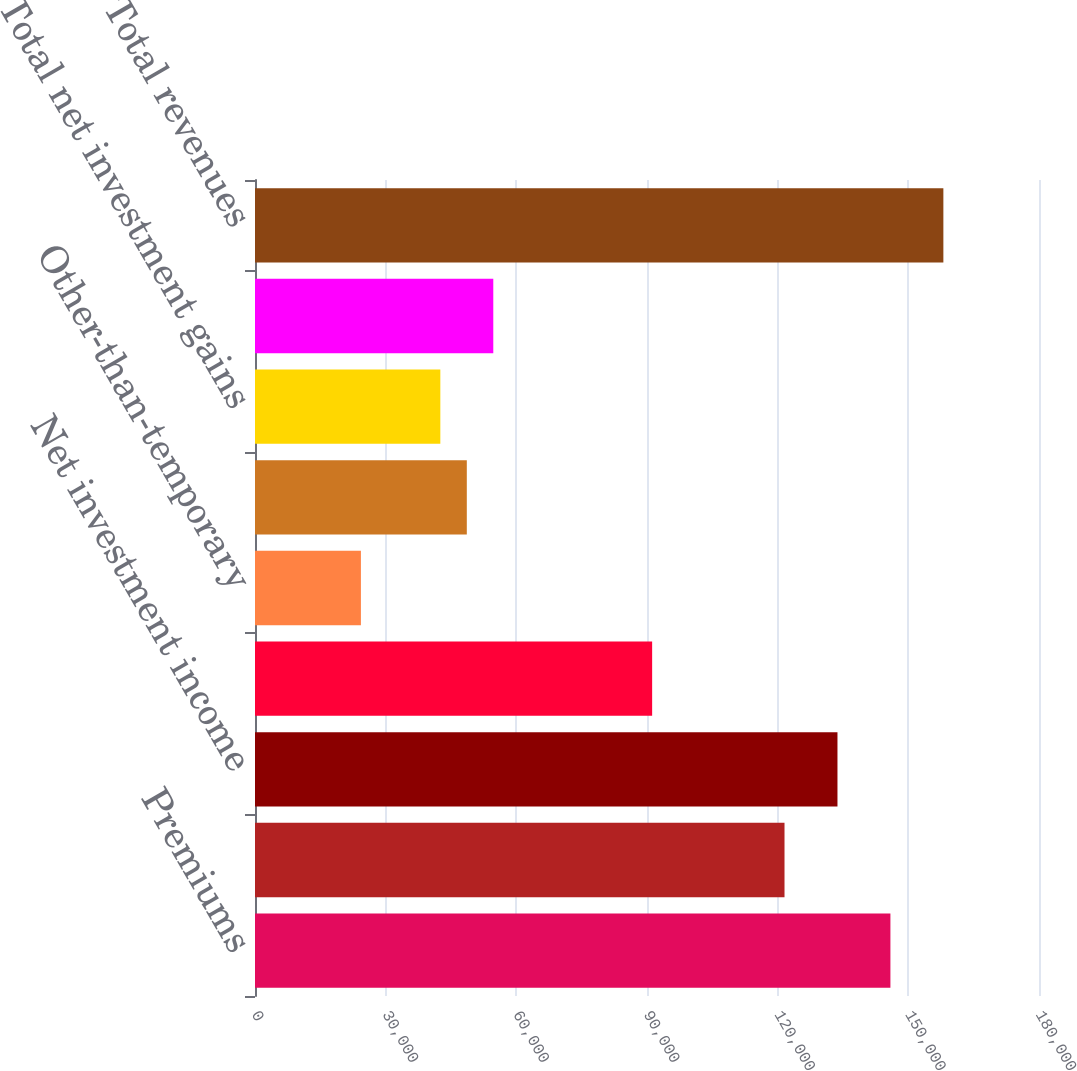<chart> <loc_0><loc_0><loc_500><loc_500><bar_chart><fcel>Premiums<fcel>Universal life and<fcel>Net investment income<fcel>Other revenues<fcel>Other-than-temporary<fcel>Other net investment gains<fcel>Total net investment gains<fcel>Net derivative gains (losses)<fcel>Total revenues<nl><fcel>145887<fcel>121572<fcel>133729<fcel>91179.7<fcel>24315.7<fcel>48629.9<fcel>42551.3<fcel>54708.4<fcel>158044<nl></chart> 